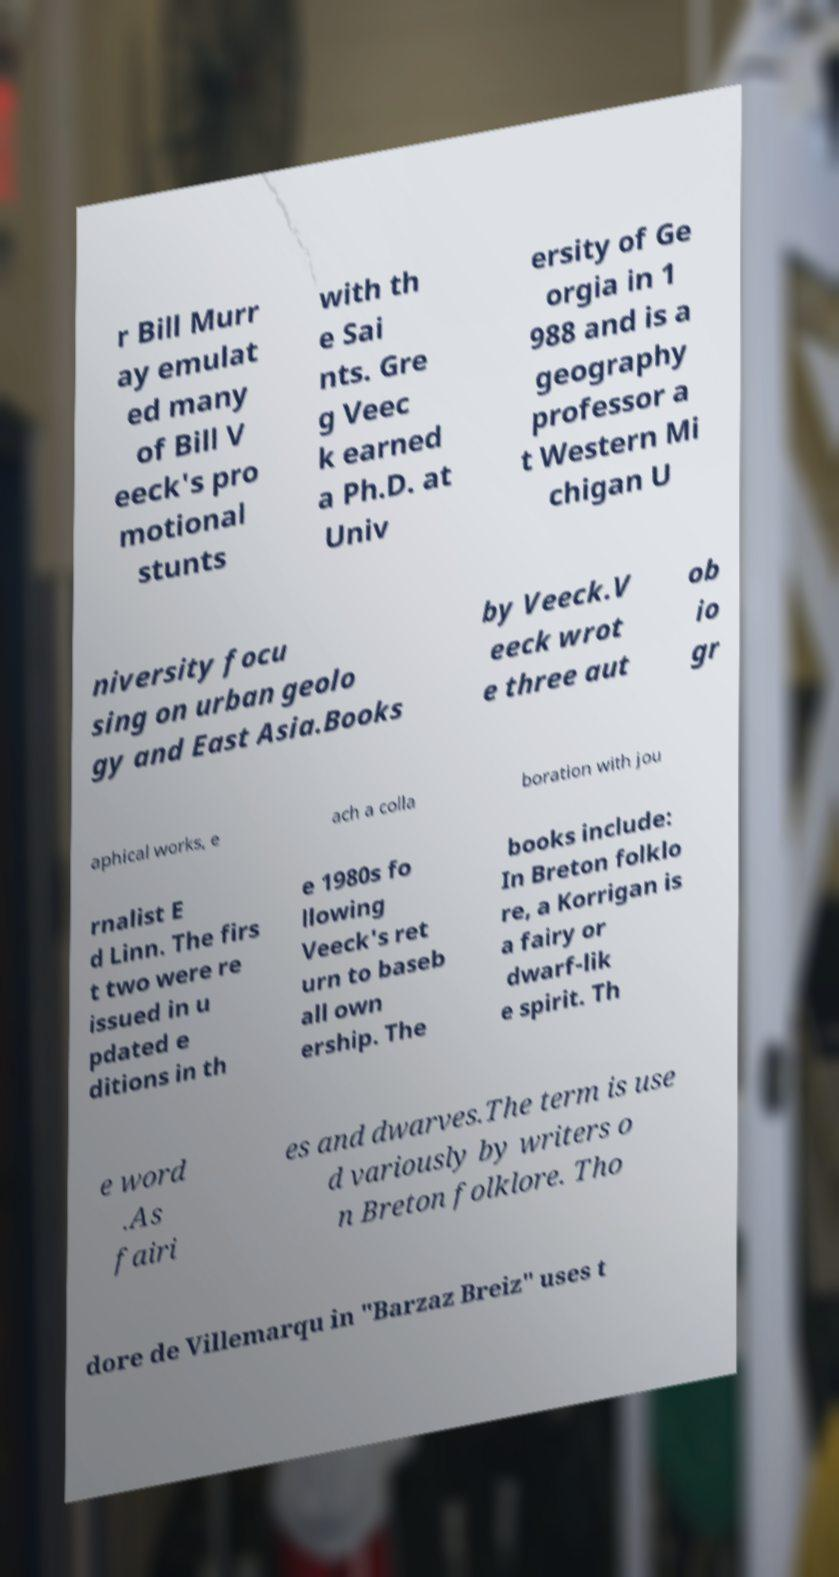Please identify and transcribe the text found in this image. r Bill Murr ay emulat ed many of Bill V eeck's pro motional stunts with th e Sai nts. Gre g Veec k earned a Ph.D. at Univ ersity of Ge orgia in 1 988 and is a geography professor a t Western Mi chigan U niversity focu sing on urban geolo gy and East Asia.Books by Veeck.V eeck wrot e three aut ob io gr aphical works, e ach a colla boration with jou rnalist E d Linn. The firs t two were re issued in u pdated e ditions in th e 1980s fo llowing Veeck's ret urn to baseb all own ership. The books include: In Breton folklo re, a Korrigan is a fairy or dwarf-lik e spirit. Th e word .As fairi es and dwarves.The term is use d variously by writers o n Breton folklore. Tho dore de Villemarqu in "Barzaz Breiz" uses t 